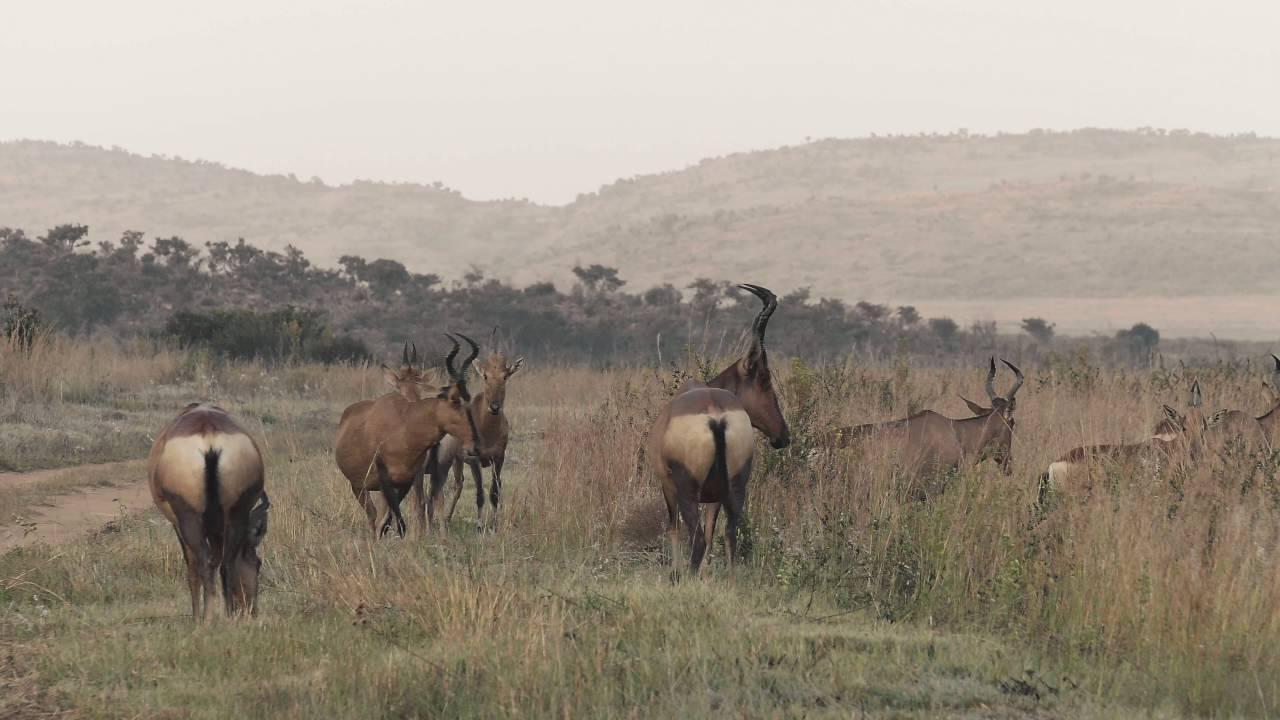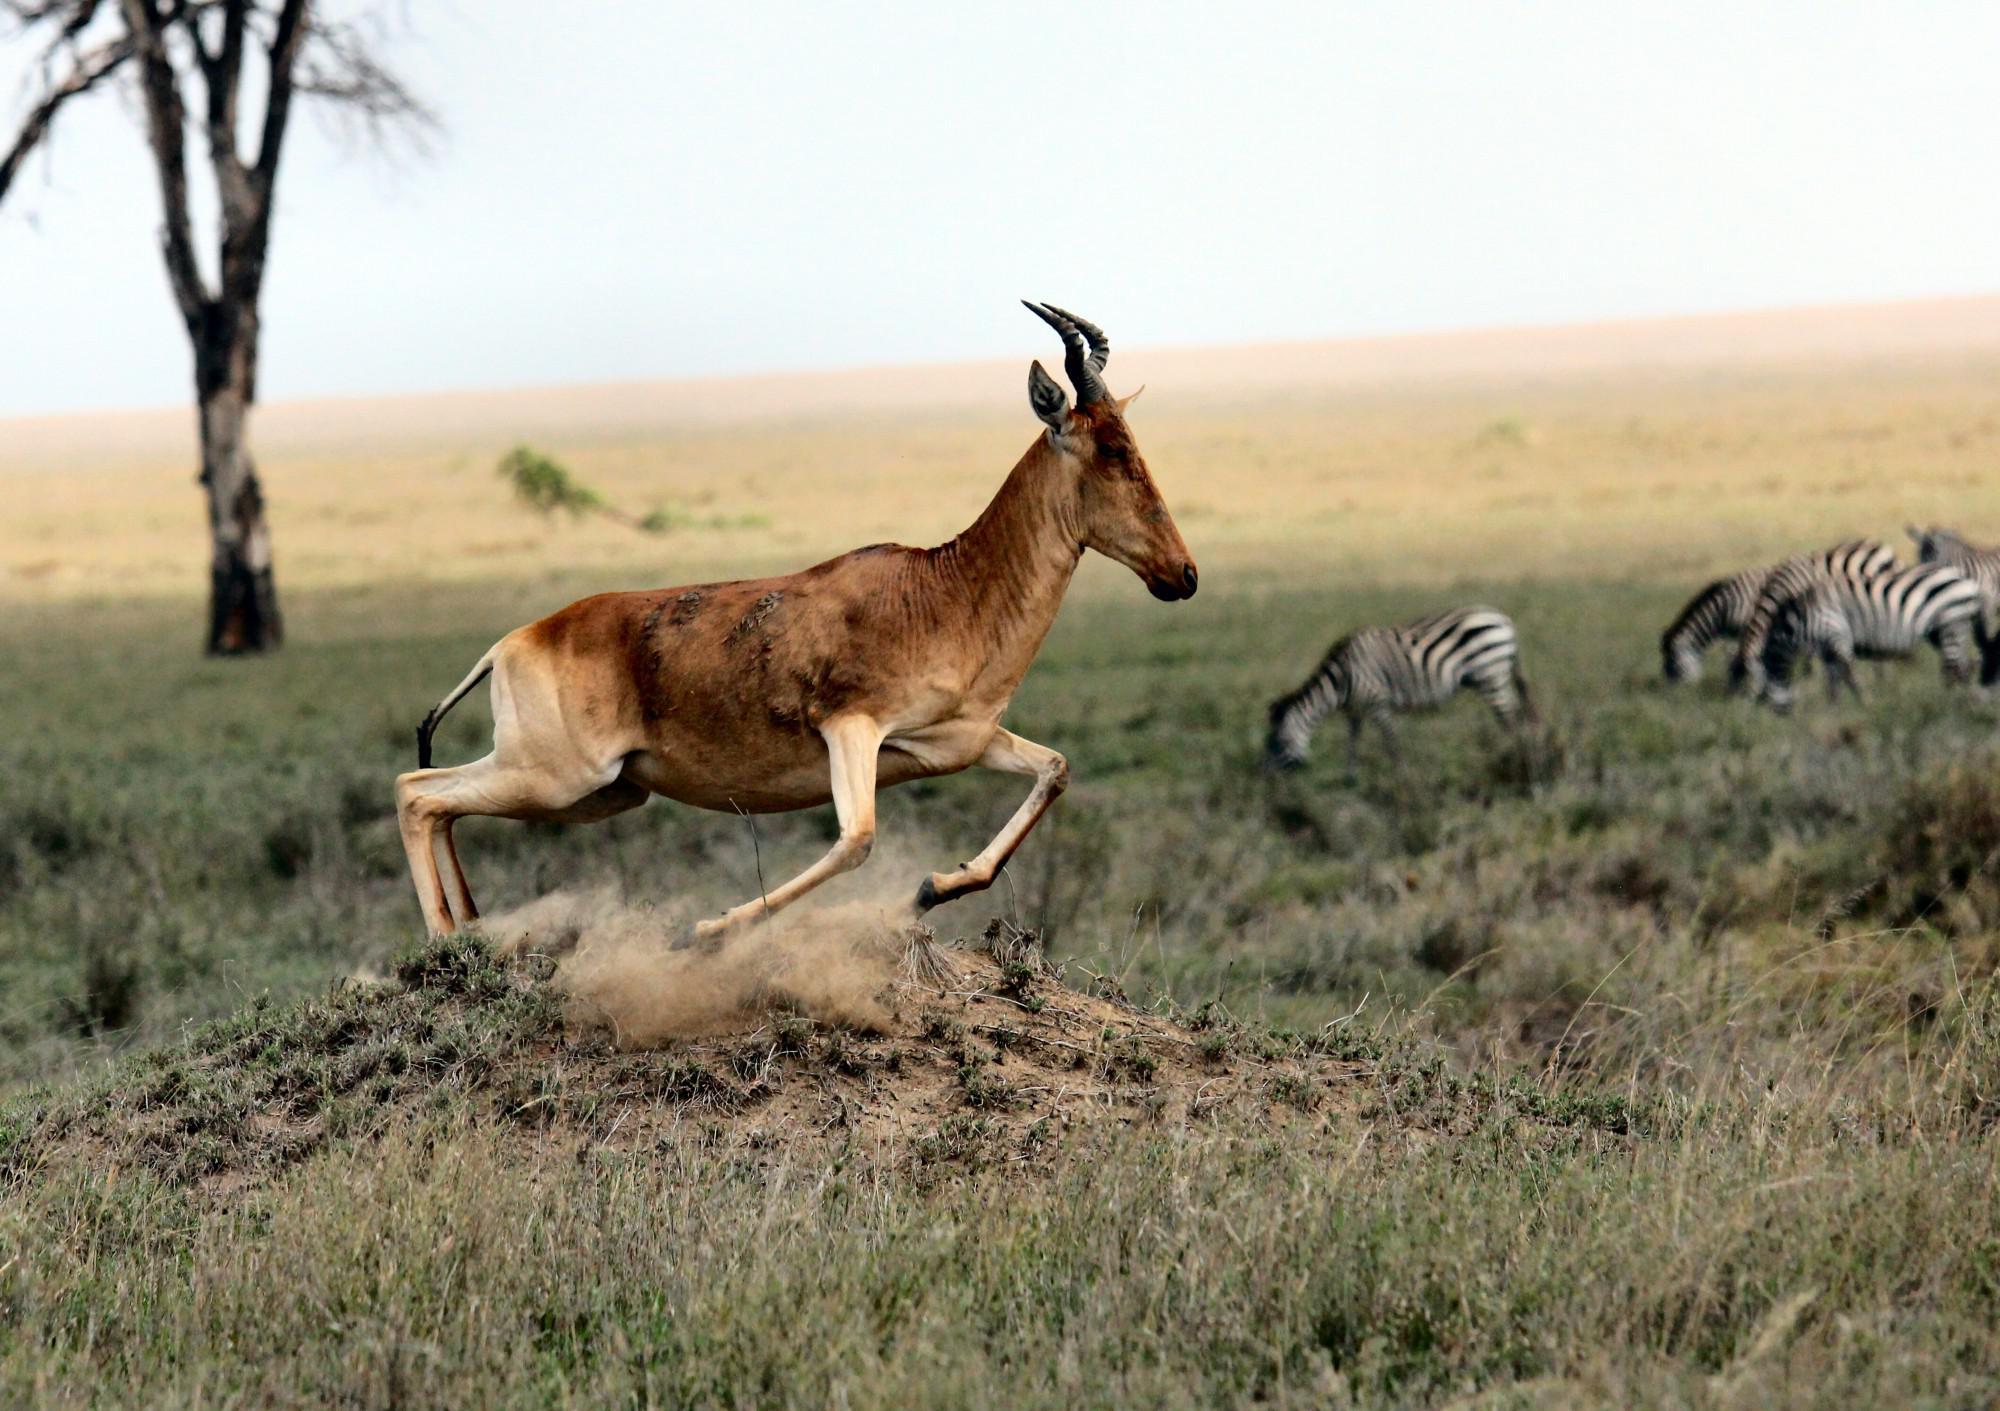The first image is the image on the left, the second image is the image on the right. Examine the images to the left and right. Is the description "Zebras are near the horned animals in the image on the right." accurate? Answer yes or no. Yes. The first image is the image on the left, the second image is the image on the right. Analyze the images presented: Is the assertion "An image includes multiple zebra and at least one brown horned animal." valid? Answer yes or no. Yes. 